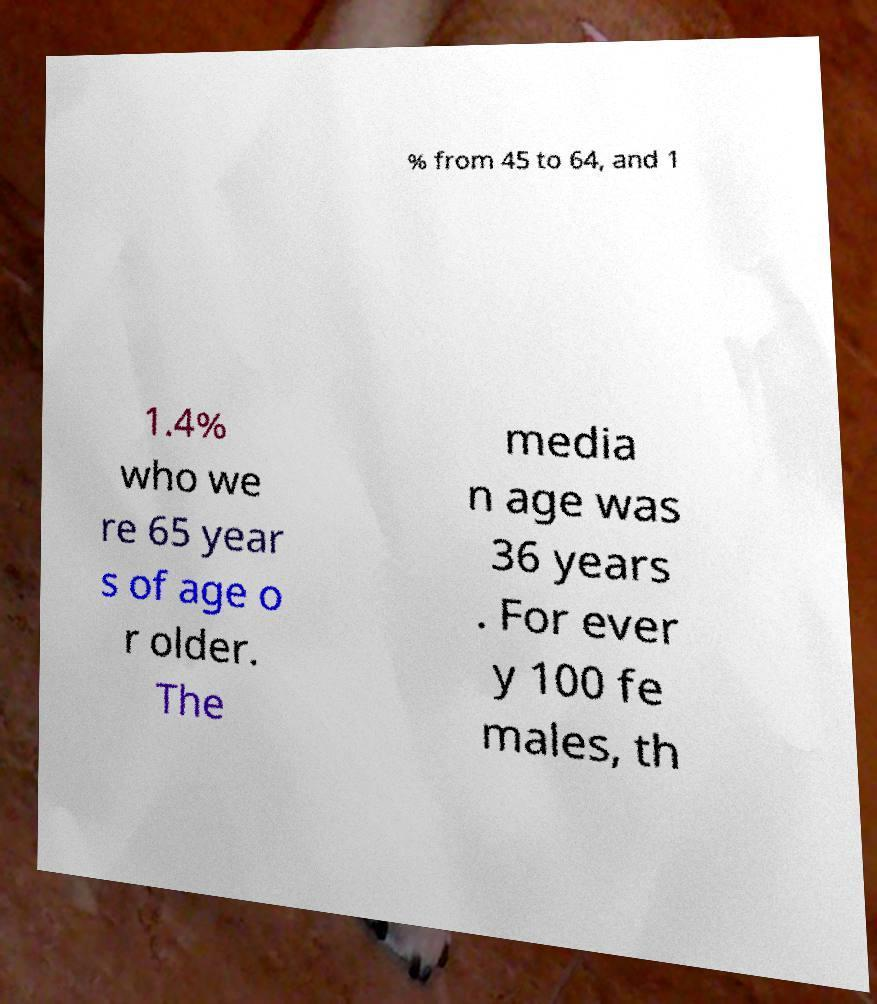There's text embedded in this image that I need extracted. Can you transcribe it verbatim? % from 45 to 64, and 1 1.4% who we re 65 year s of age o r older. The media n age was 36 years . For ever y 100 fe males, th 